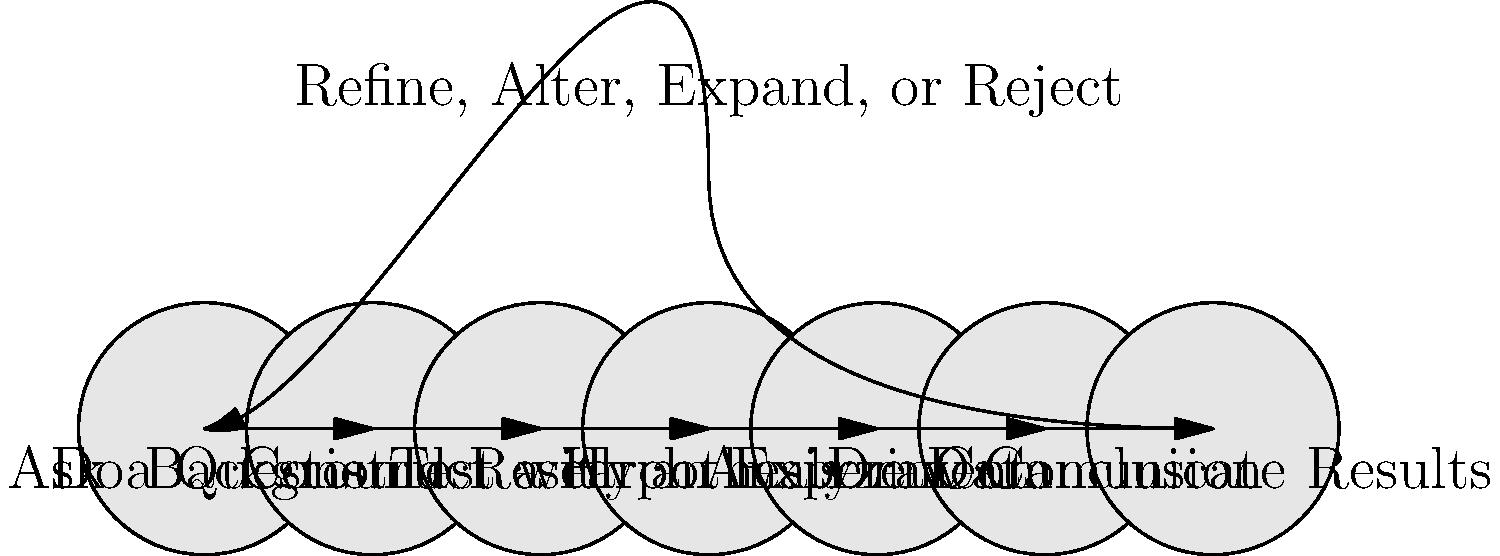In the context of implementing AI algorithms in daily purpose appliances, which step of the scientific method would be most appropriate for determining if a new machine learning model improves the energy efficiency of a smart thermostat? To answer this question, let's consider the steps of the scientific method as shown in the diagram and how they relate to implementing AI algorithms in appliances:

1. Ask a Question: This step has already been done implicitly (Can a new ML model improve energy efficiency?)
2. Do Background Research: This involves studying existing smart thermostat systems and energy efficiency models.
3. Construct a Hypothesis: Formulate a specific, testable hypothesis about the new ML model's impact on energy efficiency.
4. Test with an Experiment: Design and conduct an experiment to test the hypothesis, which would involve implementing the new ML model in a controlled setting.
5. Analyze Data: Collect and analyze data from the experiment, comparing energy usage with and without the new ML model.
6. Draw Conclusion: Based on the data analysis, conclude whether the new ML model improves energy efficiency.
7. Communicate Results: Share findings with the development team or in technical documentation.

In this scenario, the most appropriate step for determining if the new machine learning model improves energy efficiency would be "Test with an Experiment". This step allows for the practical implementation and evaluation of the new model in a controlled environment, providing concrete data on its performance and impact on energy efficiency.
Answer: Test with an Experiment 